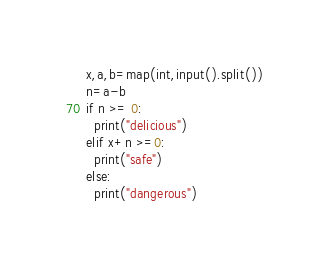<code> <loc_0><loc_0><loc_500><loc_500><_Python_>x,a,b=map(int,input().split())
n=a-b
if n >= 0:
  print("delicious")
elif x+n >=0:
  print("safe")
else:
  print("dangerous")</code> 